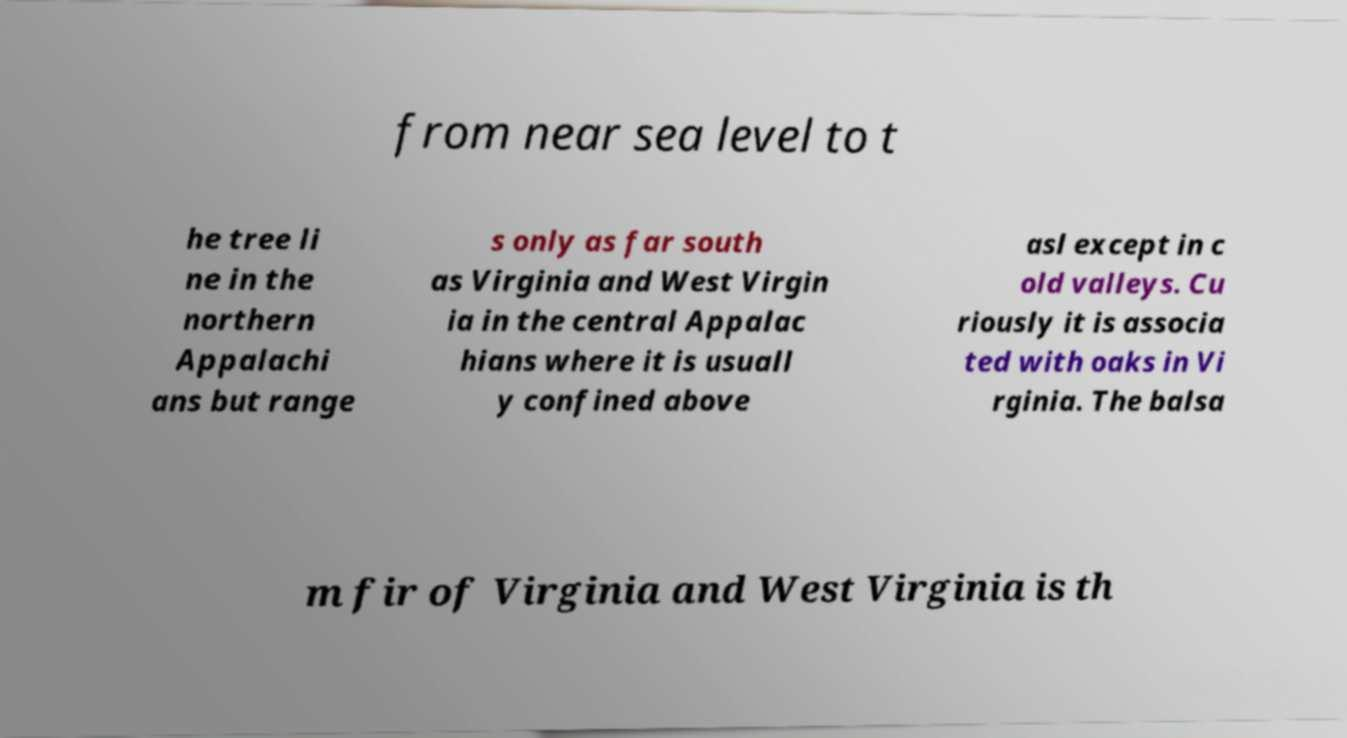Can you accurately transcribe the text from the provided image for me? from near sea level to t he tree li ne in the northern Appalachi ans but range s only as far south as Virginia and West Virgin ia in the central Appalac hians where it is usuall y confined above asl except in c old valleys. Cu riously it is associa ted with oaks in Vi rginia. The balsa m fir of Virginia and West Virginia is th 